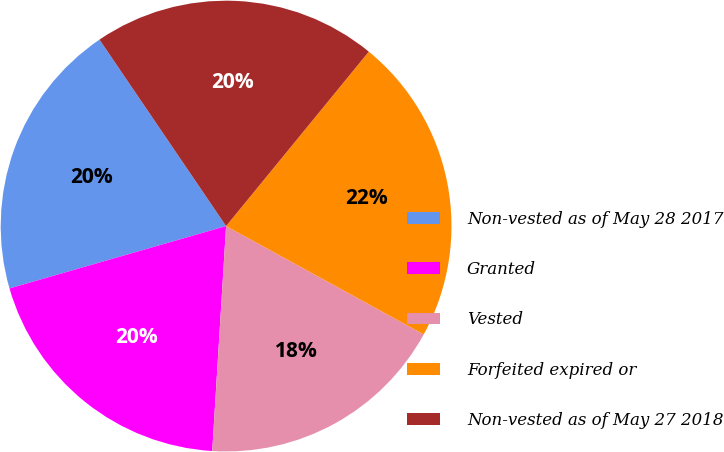Convert chart. <chart><loc_0><loc_0><loc_500><loc_500><pie_chart><fcel>Non-vested as of May 28 2017<fcel>Granted<fcel>Vested<fcel>Forfeited expired or<fcel>Non-vested as of May 27 2018<nl><fcel>19.97%<fcel>19.56%<fcel>18.0%<fcel>22.07%<fcel>20.41%<nl></chart> 